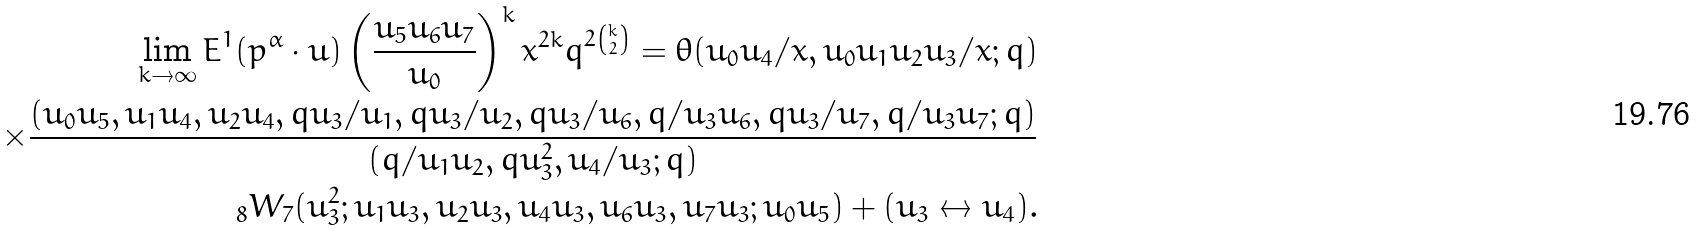Convert formula to latex. <formula><loc_0><loc_0><loc_500><loc_500>\lim _ { k \to \infty } E ^ { 1 } ( p ^ { \alpha } \cdot u ) \left ( \frac { u _ { 5 } u _ { 6 } u _ { 7 } } { u _ { 0 } } \right ) ^ { k } x ^ { 2 k } q ^ { 2 \binom { k } { 2 } } = \theta ( u _ { 0 } u _ { 4 } / x , u _ { 0 } u _ { 1 } u _ { 2 } u _ { 3 } / x ; q ) \\ \times \frac { ( u _ { 0 } u _ { 5 } , u _ { 1 } u _ { 4 } , u _ { 2 } u _ { 4 } , q u _ { 3 } / u _ { 1 } , q u _ { 3 } / u _ { 2 } , q u _ { 3 } / u _ { 6 } , q / u _ { 3 } u _ { 6 } , q u _ { 3 } / u _ { 7 } , q / u _ { 3 } u _ { 7 } ; q ) } { ( q / u _ { 1 } u _ { 2 } , q u _ { 3 } ^ { 2 } , u _ { 4 } / u _ { 3 } ; q ) } \\ _ { 8 } W _ { 7 } ( u _ { 3 } ^ { 2 } ; u _ { 1 } u _ { 3 } , u _ { 2 } u _ { 3 } , u _ { 4 } u _ { 3 } , u _ { 6 } u _ { 3 } , u _ { 7 } u _ { 3 } ; u _ { 0 } u _ { 5 } ) + ( u _ { 3 } \leftrightarrow u _ { 4 } ) .</formula> 